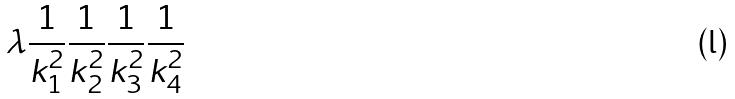<formula> <loc_0><loc_0><loc_500><loc_500>\lambda \frac { 1 } { k _ { 1 } ^ { 2 } } \frac { 1 } { k _ { 2 } ^ { 2 } } \frac { 1 } { k _ { 3 } ^ { 2 } } \frac { 1 } { k _ { 4 } ^ { 2 } }</formula> 